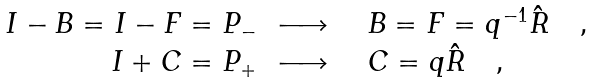Convert formula to latex. <formula><loc_0><loc_0><loc_500><loc_500>\begin{array} { r l } I - B = I - F = P _ { - } & \, \longrightarrow \quad B = F = q ^ { - 1 } \hat { R } \quad , \\ I + C = P _ { + } & \, \longrightarrow \quad C = q \hat { R } \quad , \end{array}</formula> 